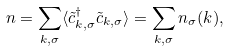Convert formula to latex. <formula><loc_0><loc_0><loc_500><loc_500>n = \sum _ { { k } , \sigma } \langle \tilde { c } ^ { \dagger } _ { { k } , \sigma } \tilde { c } _ { { k } , \sigma } \rangle = \sum _ { { k } , \sigma } n _ { \sigma } ( { k } ) ,</formula> 